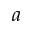Convert formula to latex. <formula><loc_0><loc_0><loc_500><loc_500>a</formula> 